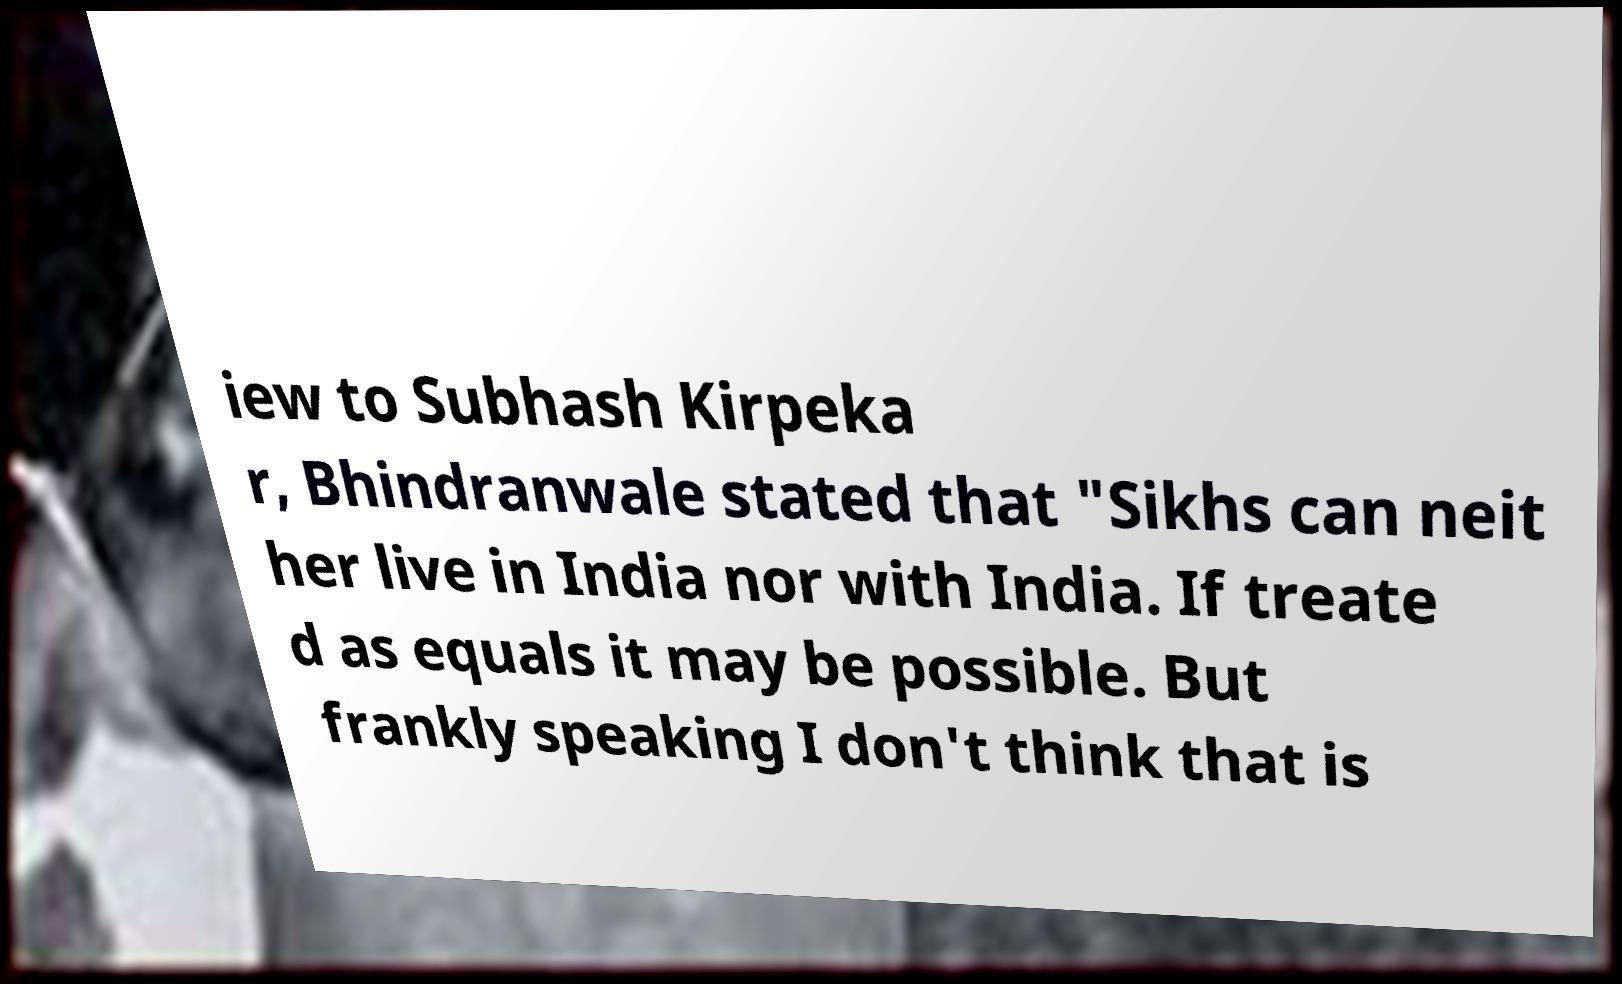I need the written content from this picture converted into text. Can you do that? iew to Subhash Kirpeka r, Bhindranwale stated that "Sikhs can neit her live in India nor with India. If treate d as equals it may be possible. But frankly speaking I don't think that is 